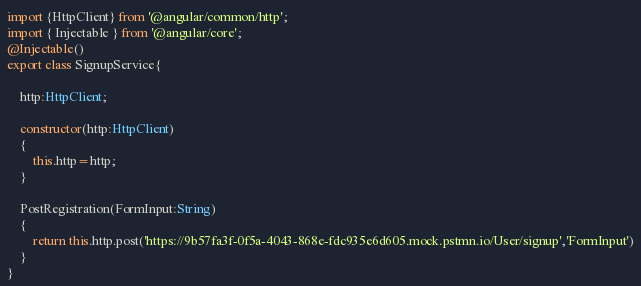Convert code to text. <code><loc_0><loc_0><loc_500><loc_500><_TypeScript_>import {HttpClient} from '@angular/common/http';
import { Injectable } from '@angular/core';
@Injectable()
export class SignupService{
    
    http:HttpClient;

    constructor(http:HttpClient)
    {
        this.http=http;
    }

    PostRegistration(FormInput:String)
    {
        return this.http.post('https://9b57fa3f-0f5a-4043-868e-fdc935e6d605.mock.pstmn.io/User/signup','FormInput')
    }
}</code> 